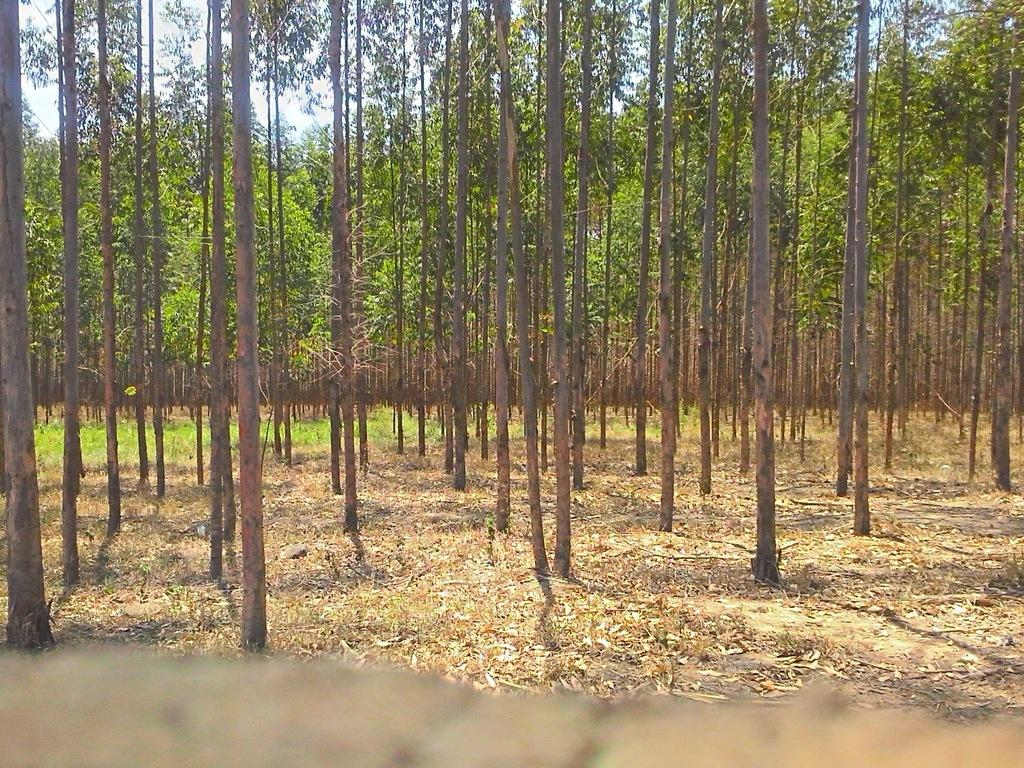What type of vegetation is present in the image? There are many trees in the image. What can be seen on the ground in the foreground? Dried leaves are on the ground in the foreground. What type of ground cover is visible in the background? There is grass on the ground in the background. What is visible at the top of the image? The sky is visible at the top of the image. Can you see a vase in the image? There is no vase present in the image. Is there an airplane flying in the sky in the image? The image does not show an airplane or any flying objects in the sky. 